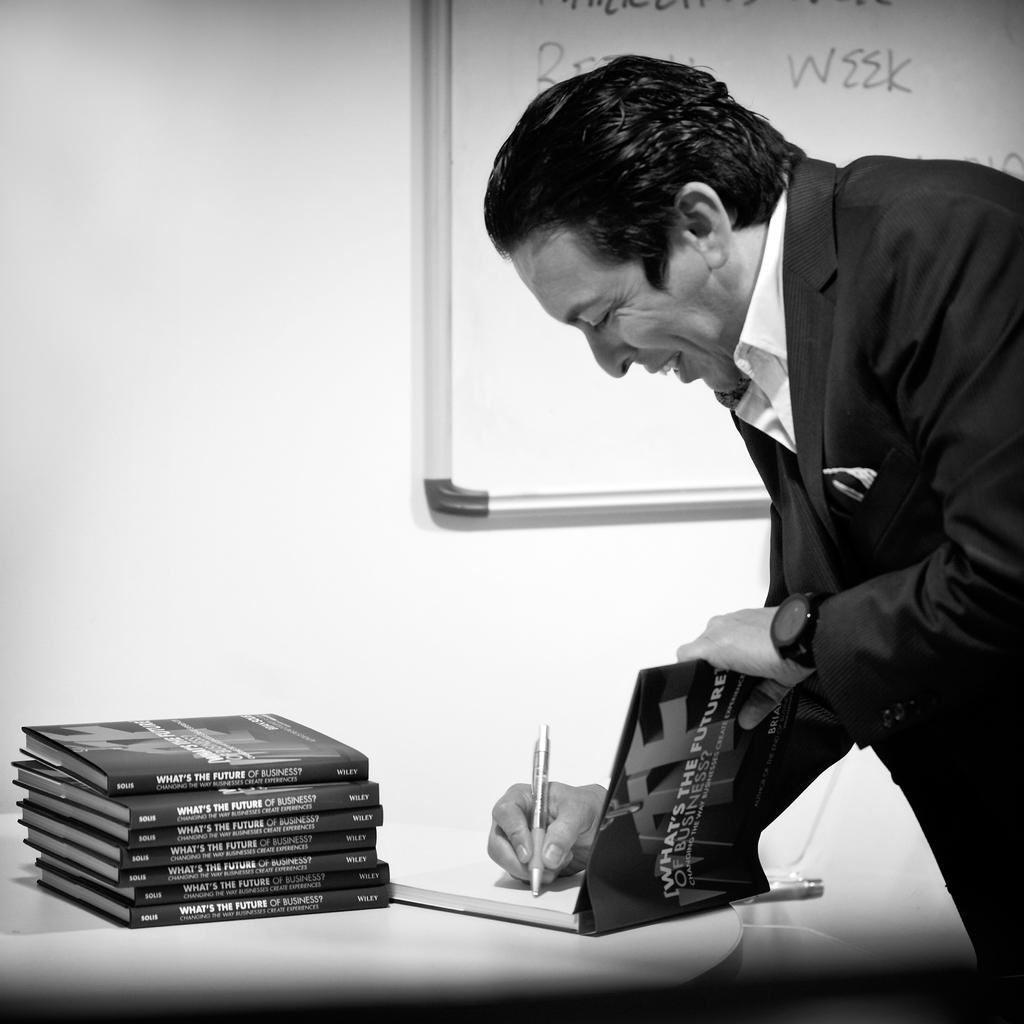<image>
Offer a succinct explanation of the picture presented. a man signing a stack of book What's the Future 